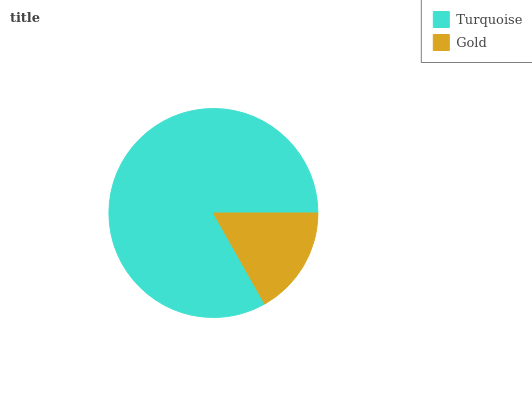Is Gold the minimum?
Answer yes or no. Yes. Is Turquoise the maximum?
Answer yes or no. Yes. Is Gold the maximum?
Answer yes or no. No. Is Turquoise greater than Gold?
Answer yes or no. Yes. Is Gold less than Turquoise?
Answer yes or no. Yes. Is Gold greater than Turquoise?
Answer yes or no. No. Is Turquoise less than Gold?
Answer yes or no. No. Is Turquoise the high median?
Answer yes or no. Yes. Is Gold the low median?
Answer yes or no. Yes. Is Gold the high median?
Answer yes or no. No. Is Turquoise the low median?
Answer yes or no. No. 